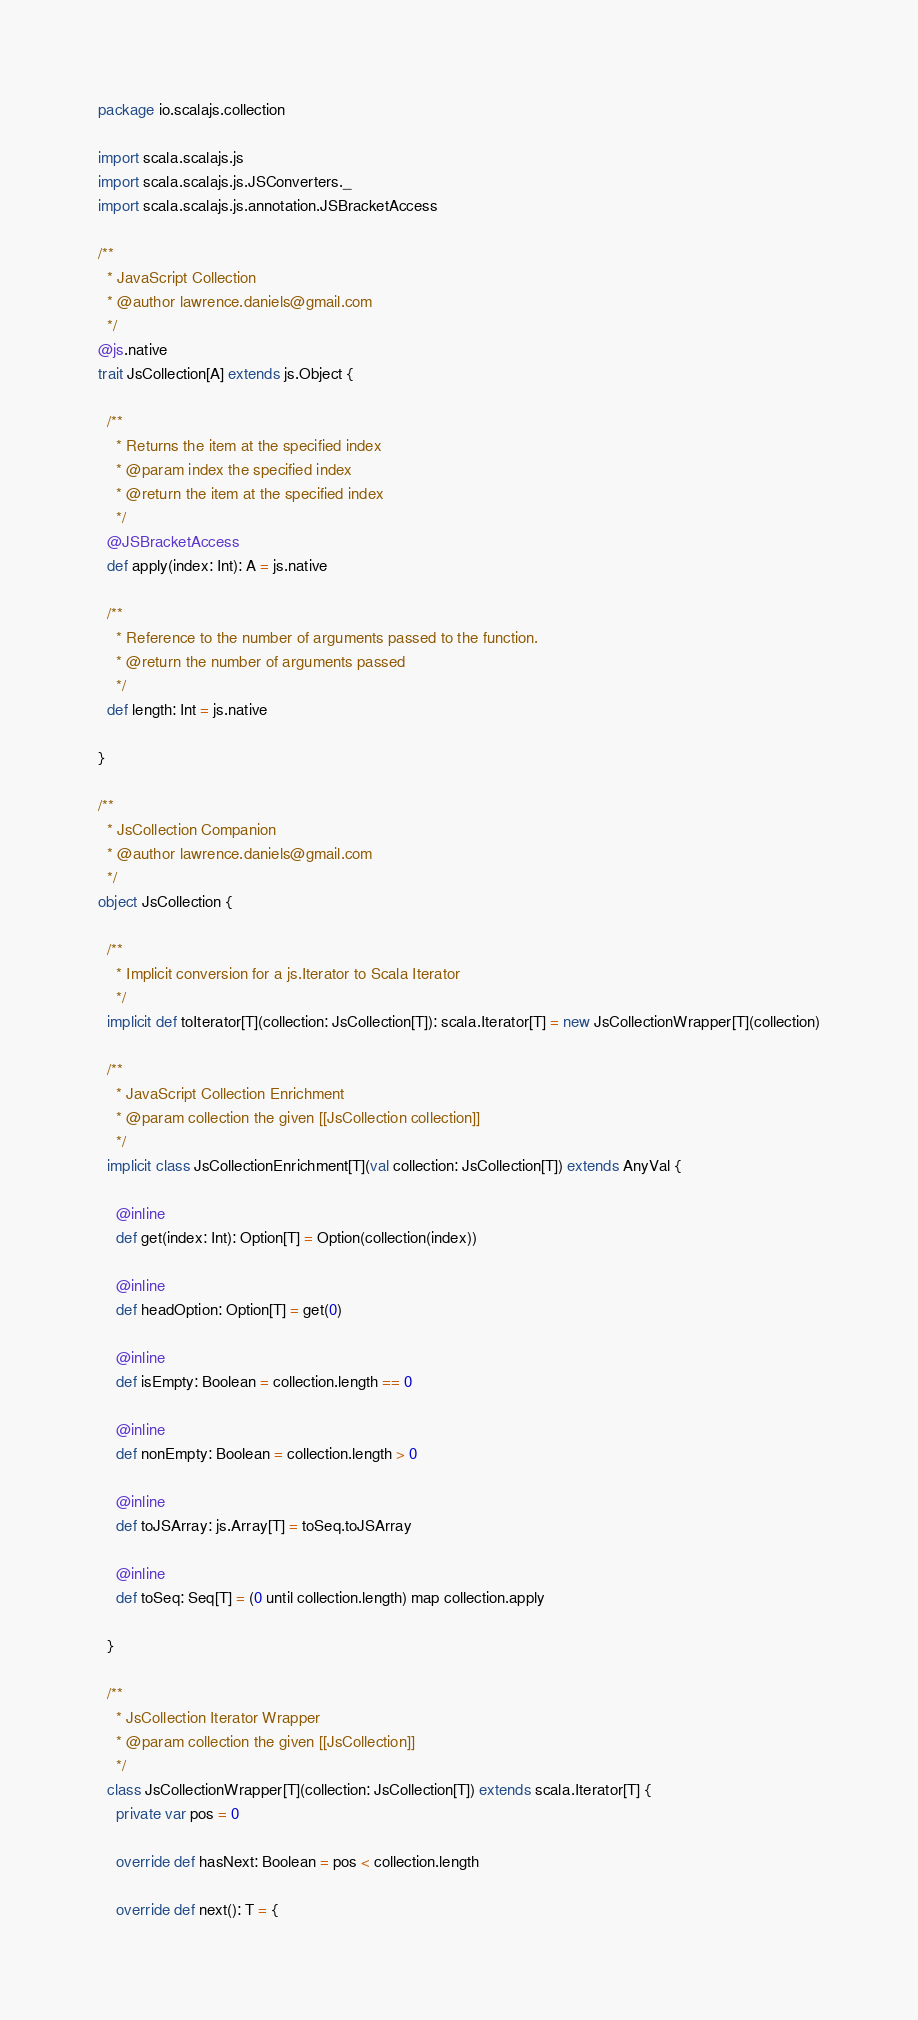Convert code to text. <code><loc_0><loc_0><loc_500><loc_500><_Scala_>package io.scalajs.collection

import scala.scalajs.js
import scala.scalajs.js.JSConverters._
import scala.scalajs.js.annotation.JSBracketAccess

/**
  * JavaScript Collection
  * @author lawrence.daniels@gmail.com
  */
@js.native
trait JsCollection[A] extends js.Object {

  /**
    * Returns the item at the specified index
    * @param index the specified index
    * @return the item at the specified index
    */
  @JSBracketAccess
  def apply(index: Int): A = js.native

  /**
    * Reference to the number of arguments passed to the function.
    * @return the number of arguments passed
    */
  def length: Int = js.native

}

/**
  * JsCollection Companion
  * @author lawrence.daniels@gmail.com
  */
object JsCollection {

  /**
    * Implicit conversion for a js.Iterator to Scala Iterator
    */
  implicit def toIterator[T](collection: JsCollection[T]): scala.Iterator[T] = new JsCollectionWrapper[T](collection)

  /**
    * JavaScript Collection Enrichment
    * @param collection the given [[JsCollection collection]]
    */
  implicit class JsCollectionEnrichment[T](val collection: JsCollection[T]) extends AnyVal {

    @inline
    def get(index: Int): Option[T] = Option(collection(index))

    @inline
    def headOption: Option[T] = get(0)

    @inline
    def isEmpty: Boolean = collection.length == 0

    @inline
    def nonEmpty: Boolean = collection.length > 0

    @inline
    def toJSArray: js.Array[T] = toSeq.toJSArray

    @inline
    def toSeq: Seq[T] = (0 until collection.length) map collection.apply

  }

  /**
    * JsCollection Iterator Wrapper
    * @param collection the given [[JsCollection]]
    */
  class JsCollectionWrapper[T](collection: JsCollection[T]) extends scala.Iterator[T] {
    private var pos = 0

    override def hasNext: Boolean = pos < collection.length

    override def next(): T = {</code> 